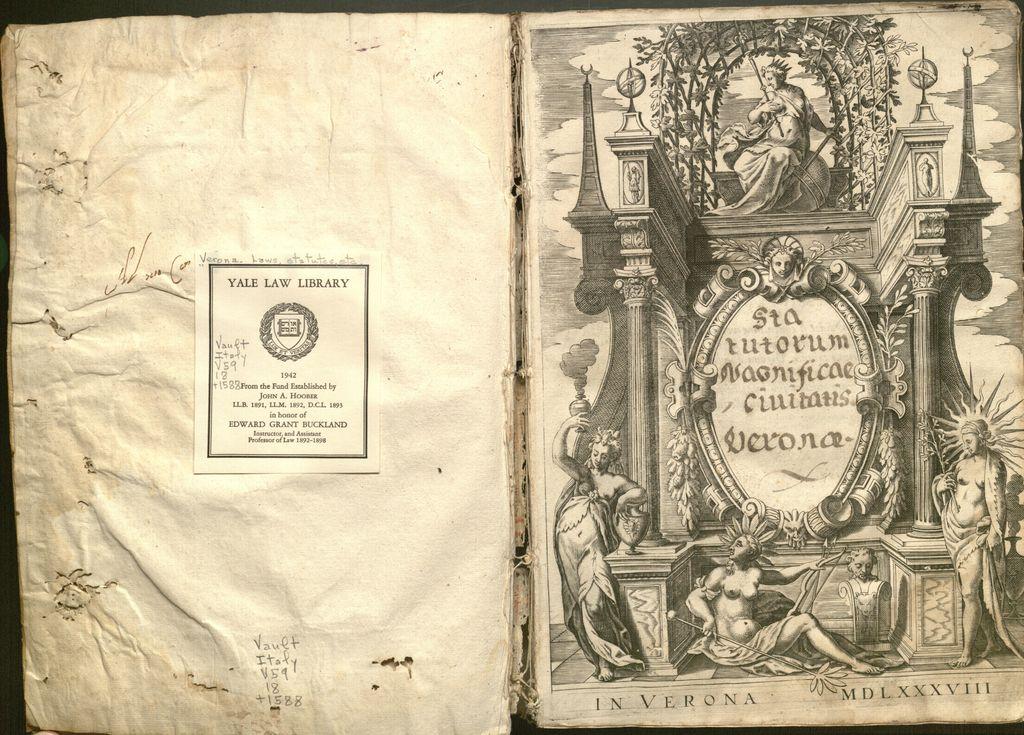What are the roman numerals at the bottom?
Ensure brevity in your answer.  Mdlxxxviii. 